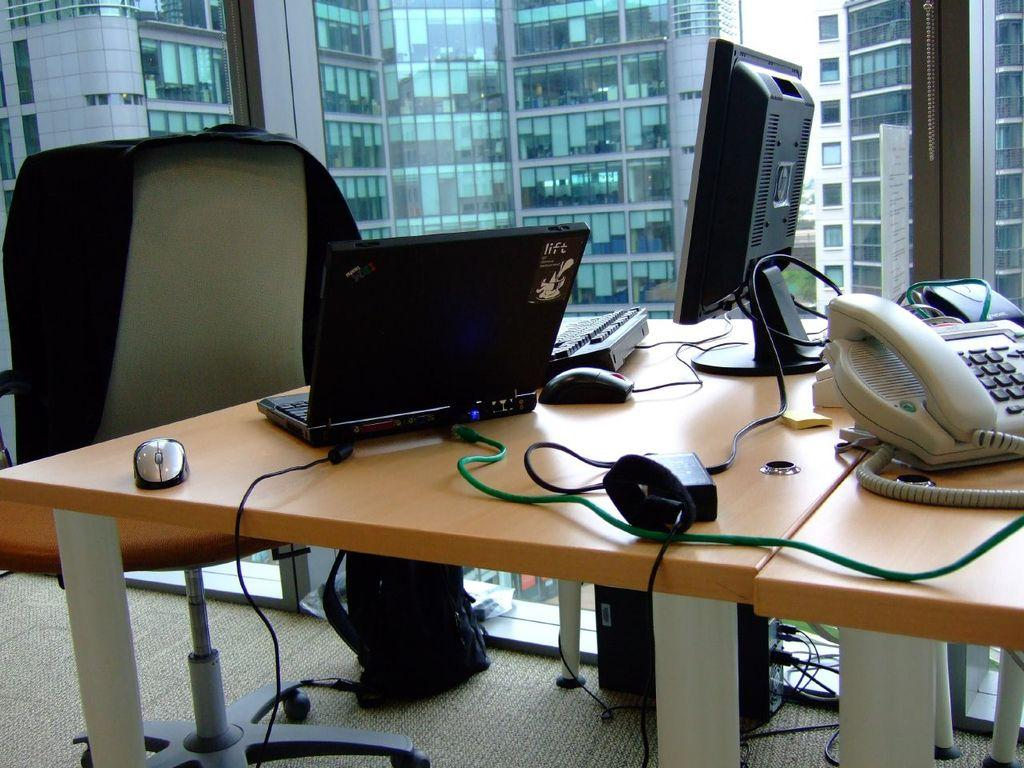What type of space is depicted in the image? There is a room in the image. What furniture is present in the room? There is a table in the room. What electronic devices are on the table? There is a laptop, a telephone, and a mouse on the table. What other object can be seen on the table? There is a battery on the table. What can be seen in the background of the image? There is a building and the sky visible in the background of the image. What type of marble is visible on the table in the image? There is no marble present on the table in the image. How does the rain affect the objects on the table in the image? There is no rain present in the image, so it does not affect the objects on the table. 